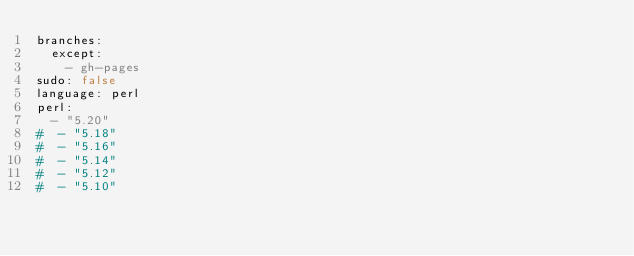Convert code to text. <code><loc_0><loc_0><loc_500><loc_500><_YAML_>branches:
  except:
    - gh-pages
sudo: false
language: perl
perl:
  - "5.20"
#  - "5.18"
#  - "5.16"
#  - "5.14"
#  - "5.12"
#  - "5.10"
</code> 